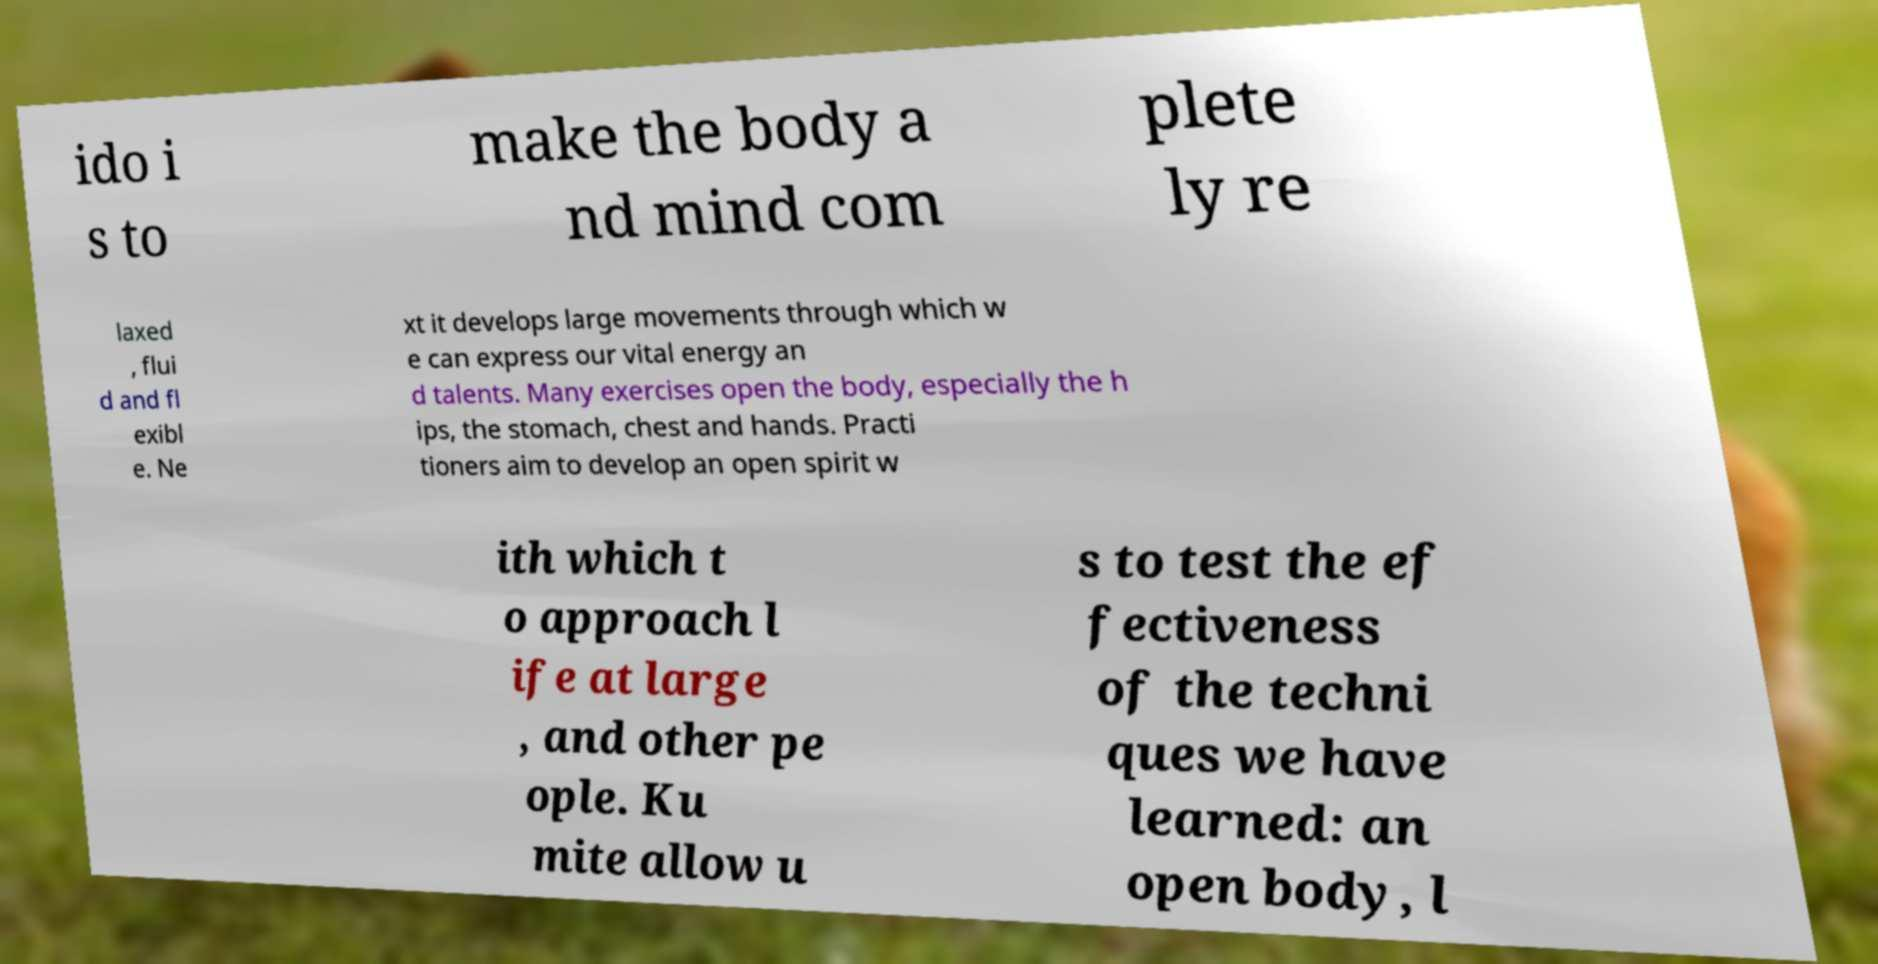Please identify and transcribe the text found in this image. ido i s to make the body a nd mind com plete ly re laxed , flui d and fl exibl e. Ne xt it develops large movements through which w e can express our vital energy an d talents. Many exercises open the body, especially the h ips, the stomach, chest and hands. Practi tioners aim to develop an open spirit w ith which t o approach l ife at large , and other pe ople. Ku mite allow u s to test the ef fectiveness of the techni ques we have learned: an open body, l 